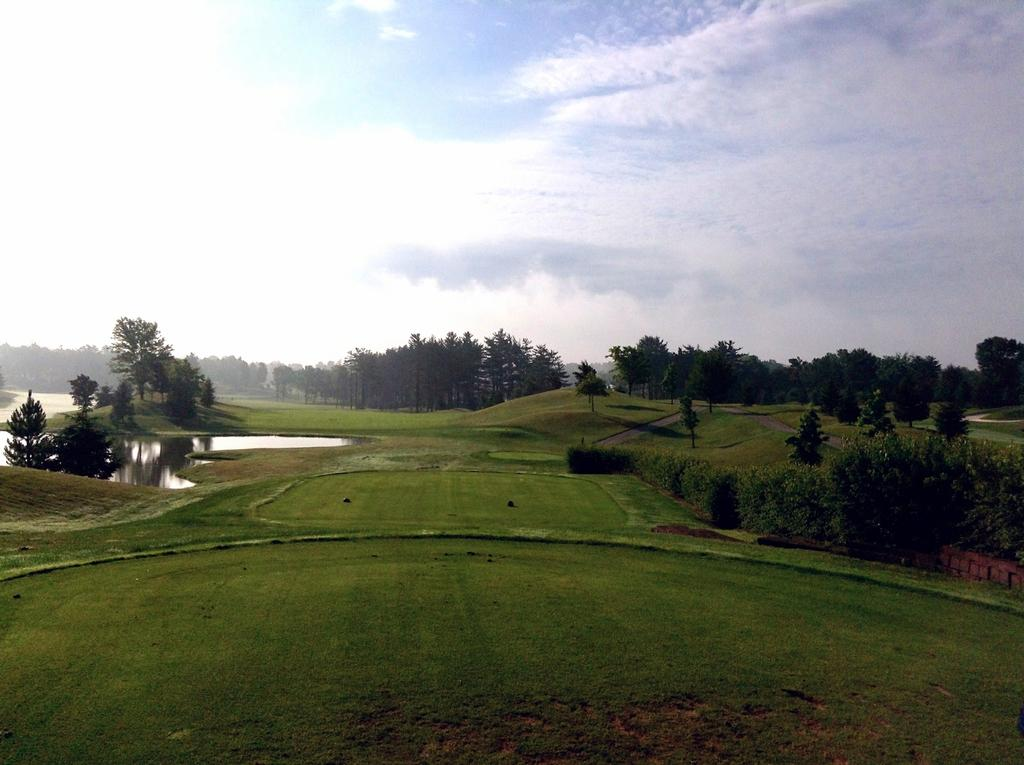What can be seen in the foreground of the image? There is greenery and water in the foreground of the image. What is visible at the top side of the image? The sky is visible at the top side of the image. How many lizards can be seen crawling on the water in the image? There are no lizards present in the image; it features greenery, water, and a visible sky. What type of test is being conducted in the image? There is no test being conducted in the image; it is a scene with greenery, water, and a visible sky. 